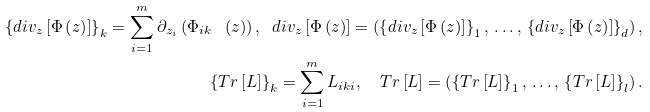Convert formula to latex. <formula><loc_0><loc_0><loc_500><loc_500>\left \{ d i v _ { z } \left [ \Phi \left ( z \right ) \right ] \right \} _ { k } = \sum _ { i = 1 } ^ { m } \partial _ { z _ { i } } \left ( \Phi _ { i k } \ \left ( z \right ) \right ) , \ d i v _ { z } \left [ \Phi \left ( z \right ) \right ] = \left ( \left \{ d i v _ { z } \left [ \Phi \left ( z \right ) \right ] \right \} _ { 1 } , \, \dots , \, \left \{ d i v _ { z } \left [ \Phi \left ( z \right ) \right ] \right \} _ { d } \right ) , \\ \left \{ T r \left [ L \right ] \right \} _ { k } = \sum _ { i = 1 } ^ { m } L _ { i k i } , \quad T r \left [ L \right ] = \left ( \left \{ T r \left [ L \right ] \right \} _ { 1 } , \, \dots , \, \left \{ T r \left [ L \right ] \right \} _ { l } \right ) .</formula> 